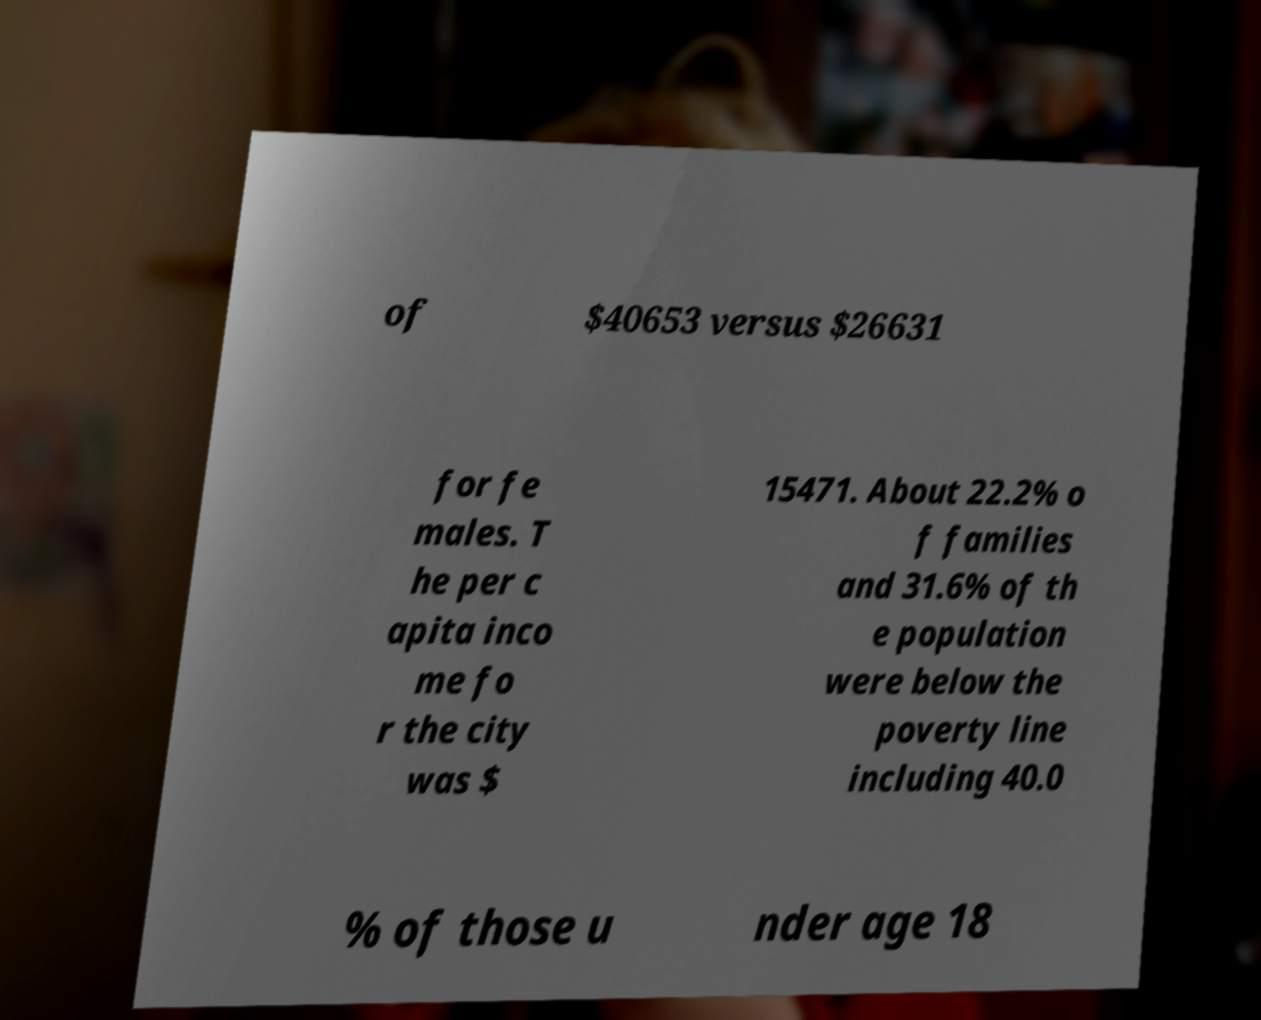What messages or text are displayed in this image? I need them in a readable, typed format. of $40653 versus $26631 for fe males. T he per c apita inco me fo r the city was $ 15471. About 22.2% o f families and 31.6% of th e population were below the poverty line including 40.0 % of those u nder age 18 